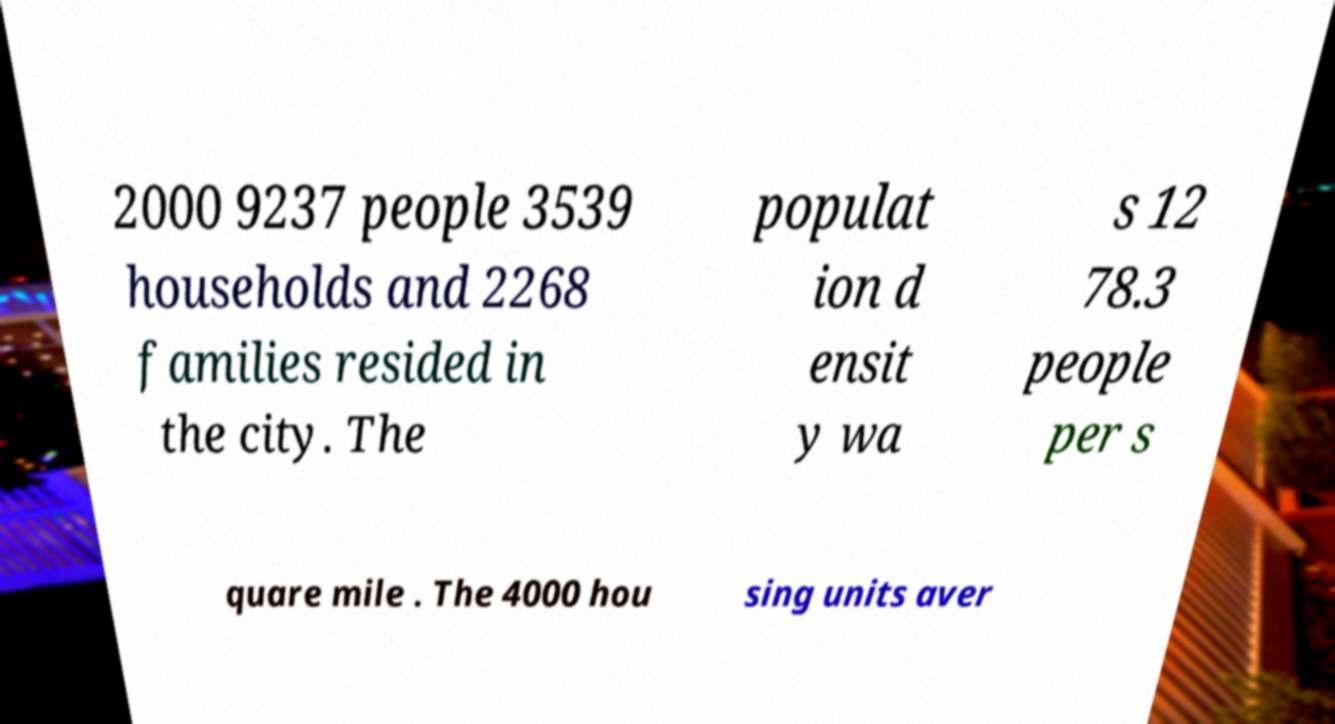Could you extract and type out the text from this image? 2000 9237 people 3539 households and 2268 families resided in the city. The populat ion d ensit y wa s 12 78.3 people per s quare mile . The 4000 hou sing units aver 